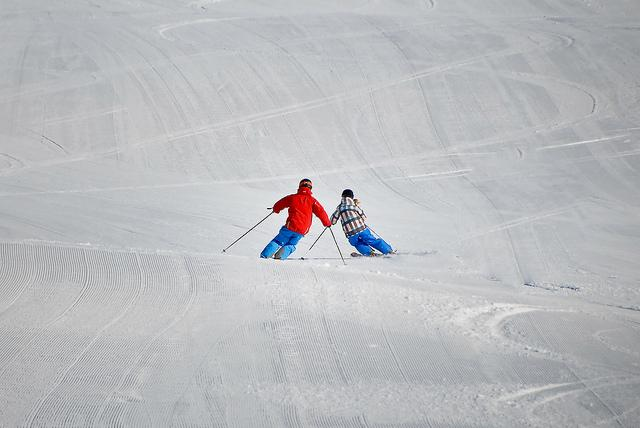What type of action are the people taking? Please explain your reasoning. descent. The action is descending. 